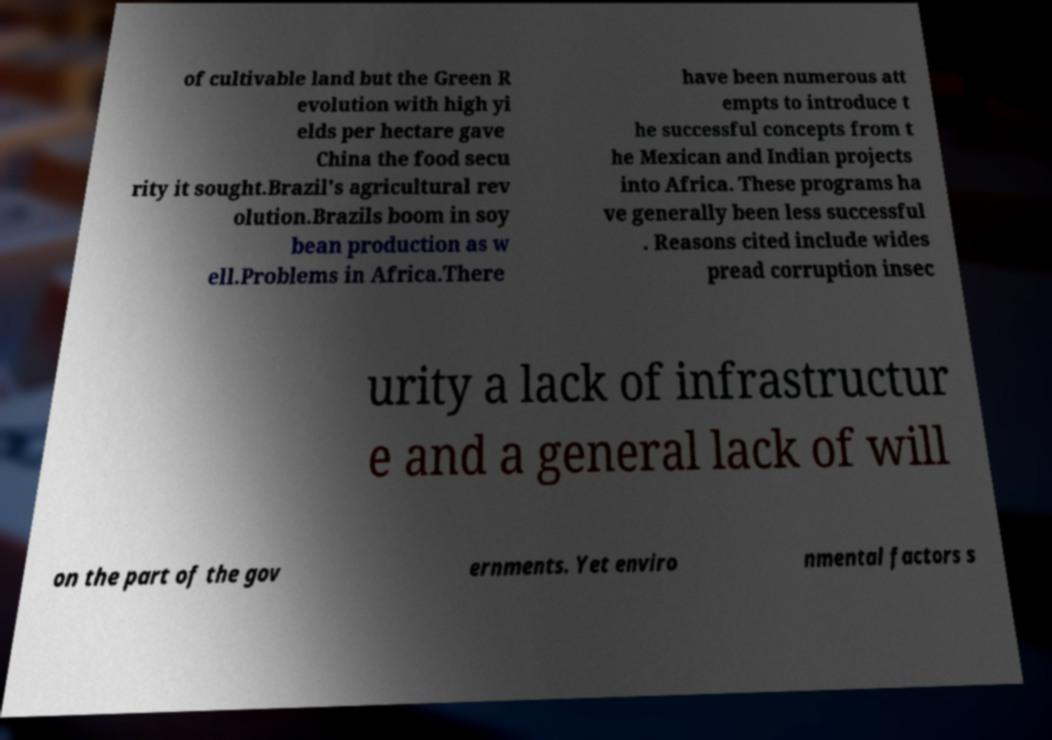Could you extract and type out the text from this image? of cultivable land but the Green R evolution with high yi elds per hectare gave China the food secu rity it sought.Brazil's agricultural rev olution.Brazils boom in soy bean production as w ell.Problems in Africa.There have been numerous att empts to introduce t he successful concepts from t he Mexican and Indian projects into Africa. These programs ha ve generally been less successful . Reasons cited include wides pread corruption insec urity a lack of infrastructur e and a general lack of will on the part of the gov ernments. Yet enviro nmental factors s 